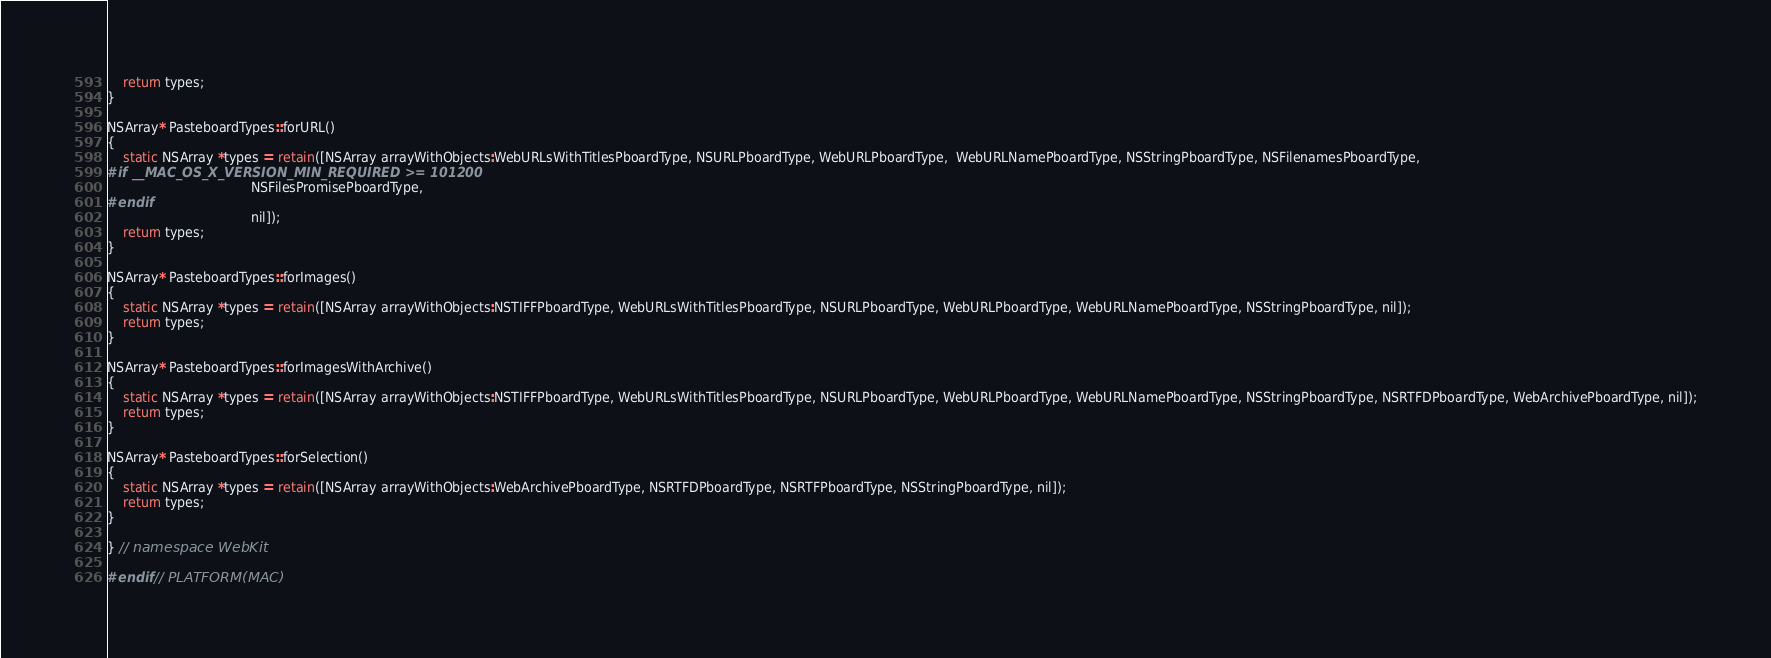Convert code to text. <code><loc_0><loc_0><loc_500><loc_500><_ObjectiveC_>    return types;
}

NSArray* PasteboardTypes::forURL()
{
    static NSArray *types = retain([NSArray arrayWithObjects:WebURLsWithTitlesPboardType, NSURLPboardType, WebURLPboardType,  WebURLNamePboardType, NSStringPboardType, NSFilenamesPboardType,
#if __MAC_OS_X_VERSION_MIN_REQUIRED >= 101200
                                    NSFilesPromisePboardType,
#endif
                                    nil]);
    return types;
}

NSArray* PasteboardTypes::forImages()
{
    static NSArray *types = retain([NSArray arrayWithObjects:NSTIFFPboardType, WebURLsWithTitlesPboardType, NSURLPboardType, WebURLPboardType, WebURLNamePboardType, NSStringPboardType, nil]);
    return types;
}

NSArray* PasteboardTypes::forImagesWithArchive()
{
    static NSArray *types = retain([NSArray arrayWithObjects:NSTIFFPboardType, WebURLsWithTitlesPboardType, NSURLPboardType, WebURLPboardType, WebURLNamePboardType, NSStringPboardType, NSRTFDPboardType, WebArchivePboardType, nil]);
    return types;
}

NSArray* PasteboardTypes::forSelection()
{
    static NSArray *types = retain([NSArray arrayWithObjects:WebArchivePboardType, NSRTFDPboardType, NSRTFPboardType, NSStringPboardType, nil]);
    return types;
}
    
} // namespace WebKit

#endif // PLATFORM(MAC)
</code> 